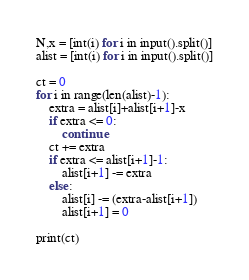<code> <loc_0><loc_0><loc_500><loc_500><_Python_>N,x = [int(i) for i in input().split()]
alist = [int(i) for i in input().split()]

ct = 0
for i in range(len(alist)-1):
    extra = alist[i]+alist[i+1]-x
    if extra <= 0:
        continue
    ct += extra
    if extra <= alist[i+1]-1:
        alist[i+1] -= extra
    else:
        alist[i] -= (extra-alist[i+1])
        alist[i+1] = 0

print(ct)</code> 